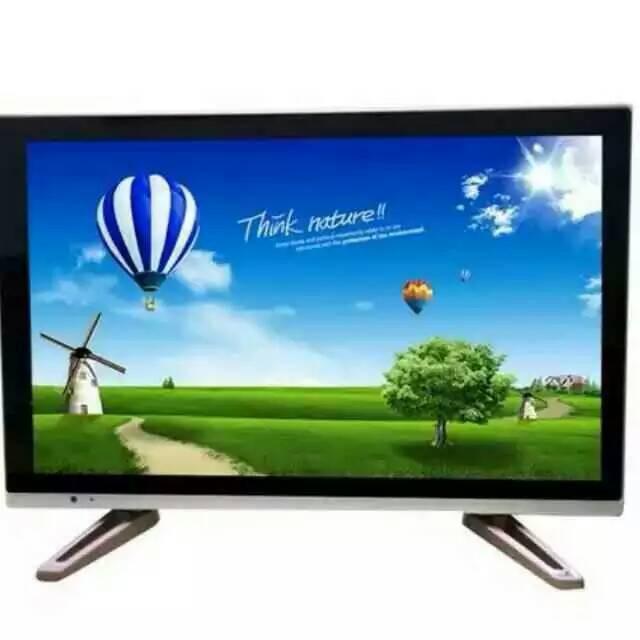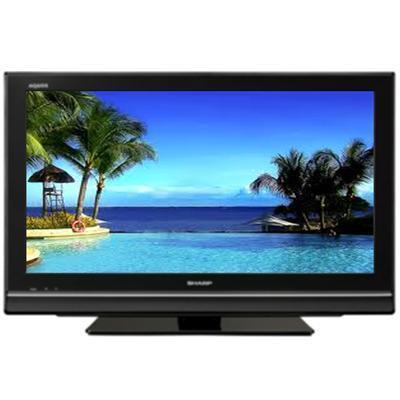The first image is the image on the left, the second image is the image on the right. For the images displayed, is the sentence "One of the screens is showing a tropical scene." factually correct? Answer yes or no. Yes. The first image is the image on the left, the second image is the image on the right. Analyze the images presented: Is the assertion "One screen is tilted to the right and shows mountains in front of a lake, and the other screen is viewed head-on and shows a different landscape scene." valid? Answer yes or no. No. 